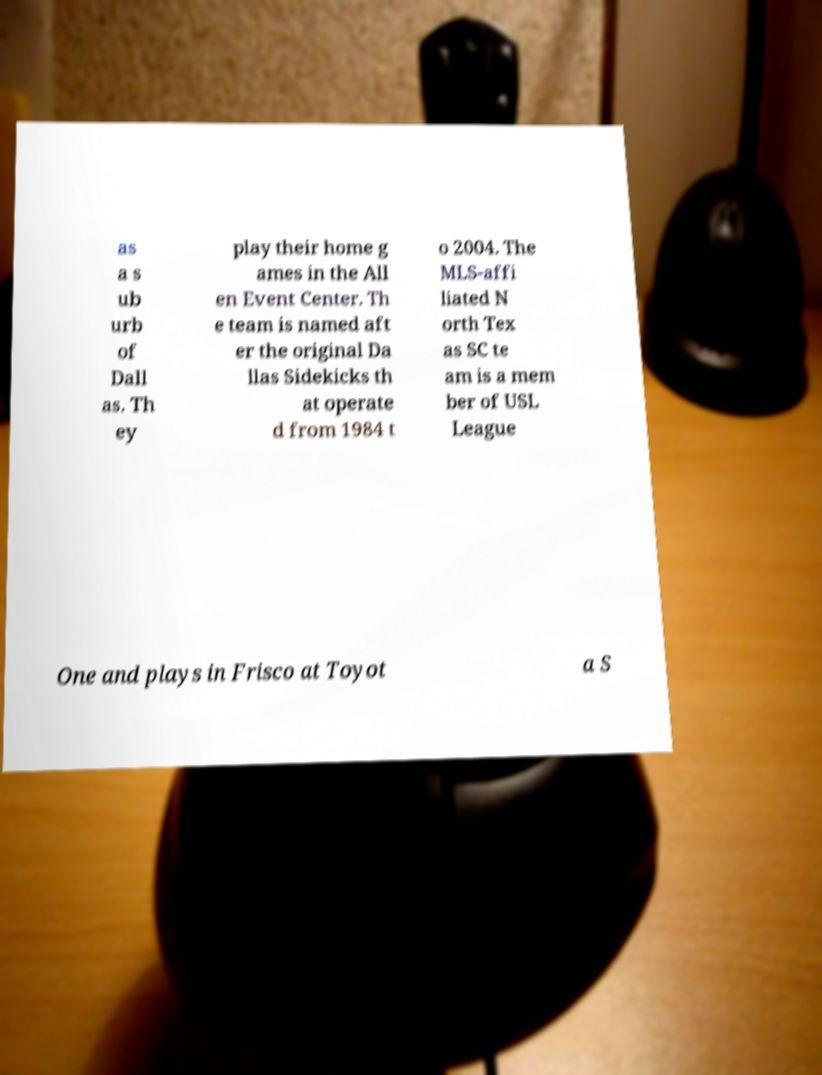I need the written content from this picture converted into text. Can you do that? as a s ub urb of Dall as. Th ey play their home g ames in the All en Event Center. Th e team is named aft er the original Da llas Sidekicks th at operate d from 1984 t o 2004. The MLS-affi liated N orth Tex as SC te am is a mem ber of USL League One and plays in Frisco at Toyot a S 